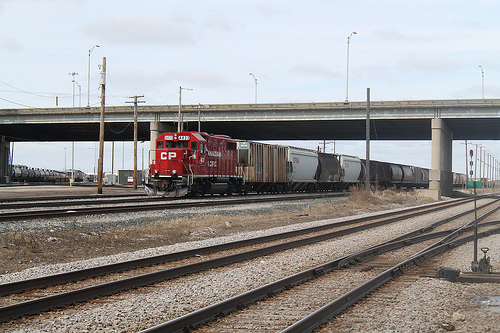<image>
Is there a post on the train? No. The post is not positioned on the train. They may be near each other, but the post is not supported by or resting on top of the train. 